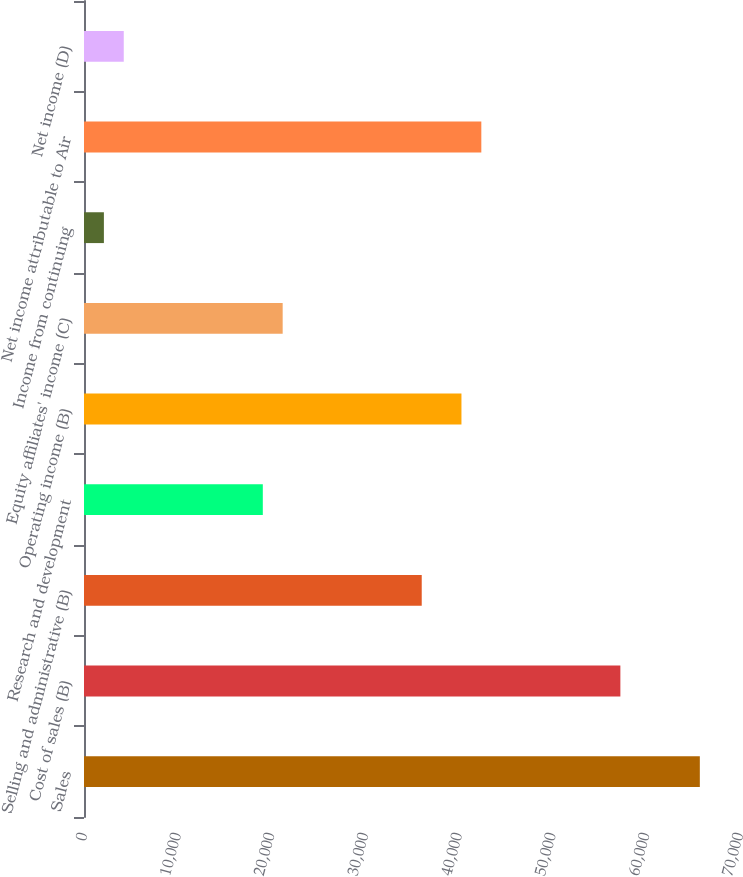Convert chart to OTSL. <chart><loc_0><loc_0><loc_500><loc_500><bar_chart><fcel>Sales<fcel>Cost of sales (B)<fcel>Selling and administrative (B)<fcel>Research and development<fcel>Operating income (B)<fcel>Equity affiliates' income (C)<fcel>Income from continuing<fcel>Net income attributable to Air<fcel>Net income (D)<nl><fcel>65713.7<fcel>57234.9<fcel>36037.9<fcel>19080.3<fcel>40277.3<fcel>21200<fcel>2122.72<fcel>42397<fcel>4242.42<nl></chart> 